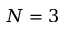Convert formula to latex. <formula><loc_0><loc_0><loc_500><loc_500>N = 3</formula> 